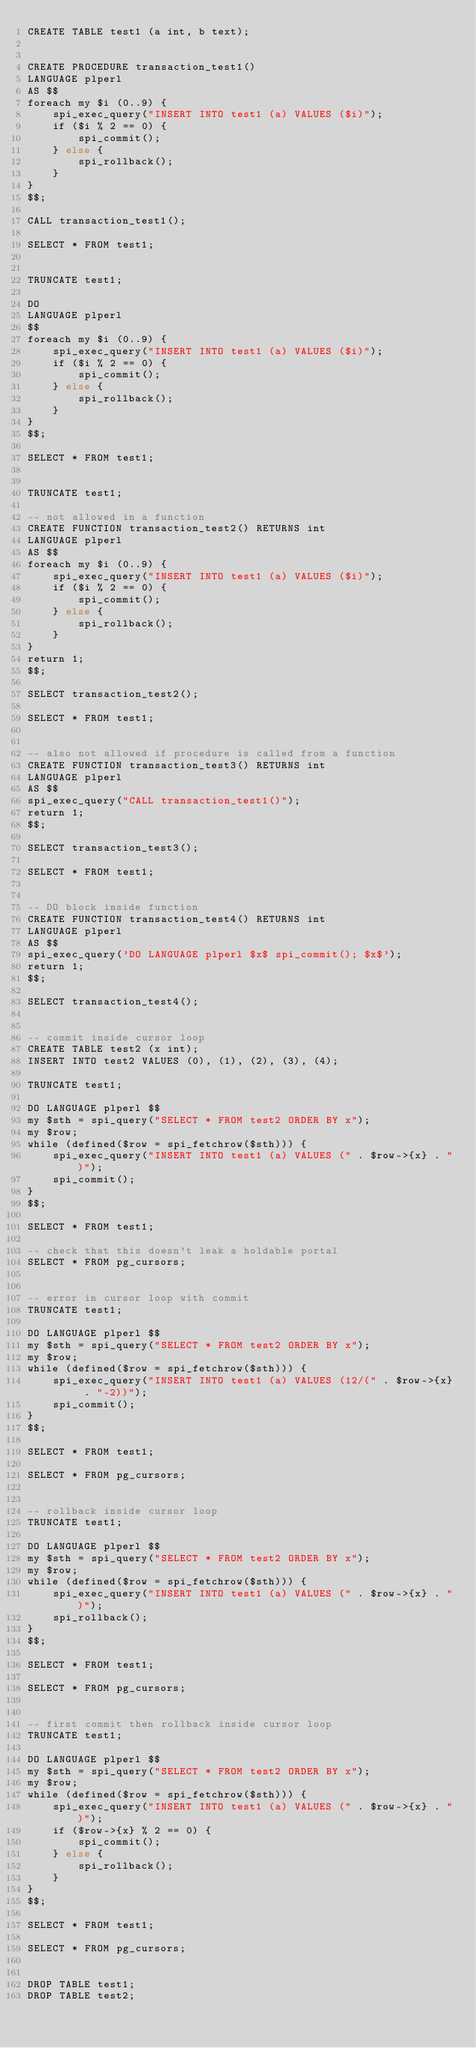Convert code to text. <code><loc_0><loc_0><loc_500><loc_500><_SQL_>CREATE TABLE test1 (a int, b text);


CREATE PROCEDURE transaction_test1()
LANGUAGE plperl
AS $$
foreach my $i (0..9) {
    spi_exec_query("INSERT INTO test1 (a) VALUES ($i)");
    if ($i % 2 == 0) {
        spi_commit();
    } else {
        spi_rollback();
    }
}
$$;

CALL transaction_test1();

SELECT * FROM test1;


TRUNCATE test1;

DO
LANGUAGE plperl
$$
foreach my $i (0..9) {
    spi_exec_query("INSERT INTO test1 (a) VALUES ($i)");
    if ($i % 2 == 0) {
        spi_commit();
    } else {
        spi_rollback();
    }
}
$$;

SELECT * FROM test1;


TRUNCATE test1;

-- not allowed in a function
CREATE FUNCTION transaction_test2() RETURNS int
LANGUAGE plperl
AS $$
foreach my $i (0..9) {
    spi_exec_query("INSERT INTO test1 (a) VALUES ($i)");
    if ($i % 2 == 0) {
        spi_commit();
    } else {
        spi_rollback();
    }
}
return 1;
$$;

SELECT transaction_test2();

SELECT * FROM test1;


-- also not allowed if procedure is called from a function
CREATE FUNCTION transaction_test3() RETURNS int
LANGUAGE plperl
AS $$
spi_exec_query("CALL transaction_test1()");
return 1;
$$;

SELECT transaction_test3();

SELECT * FROM test1;


-- DO block inside function
CREATE FUNCTION transaction_test4() RETURNS int
LANGUAGE plperl
AS $$
spi_exec_query('DO LANGUAGE plperl $x$ spi_commit(); $x$');
return 1;
$$;

SELECT transaction_test4();


-- commit inside cursor loop
CREATE TABLE test2 (x int);
INSERT INTO test2 VALUES (0), (1), (2), (3), (4);

TRUNCATE test1;

DO LANGUAGE plperl $$
my $sth = spi_query("SELECT * FROM test2 ORDER BY x");
my $row;
while (defined($row = spi_fetchrow($sth))) {
    spi_exec_query("INSERT INTO test1 (a) VALUES (" . $row->{x} . ")");
    spi_commit();
}
$$;

SELECT * FROM test1;

-- check that this doesn't leak a holdable portal
SELECT * FROM pg_cursors;


-- error in cursor loop with commit
TRUNCATE test1;

DO LANGUAGE plperl $$
my $sth = spi_query("SELECT * FROM test2 ORDER BY x");
my $row;
while (defined($row = spi_fetchrow($sth))) {
    spi_exec_query("INSERT INTO test1 (a) VALUES (12/(" . $row->{x} . "-2))");
    spi_commit();
}
$$;

SELECT * FROM test1;

SELECT * FROM pg_cursors;


-- rollback inside cursor loop
TRUNCATE test1;

DO LANGUAGE plperl $$
my $sth = spi_query("SELECT * FROM test2 ORDER BY x");
my $row;
while (defined($row = spi_fetchrow($sth))) {
    spi_exec_query("INSERT INTO test1 (a) VALUES (" . $row->{x} . ")");
    spi_rollback();
}
$$;

SELECT * FROM test1;

SELECT * FROM pg_cursors;


-- first commit then rollback inside cursor loop
TRUNCATE test1;

DO LANGUAGE plperl $$
my $sth = spi_query("SELECT * FROM test2 ORDER BY x");
my $row;
while (defined($row = spi_fetchrow($sth))) {
    spi_exec_query("INSERT INTO test1 (a) VALUES (" . $row->{x} . ")");
    if ($row->{x} % 2 == 0) {
        spi_commit();
    } else {
        spi_rollback();
    }
}
$$;

SELECT * FROM test1;

SELECT * FROM pg_cursors;


DROP TABLE test1;
DROP TABLE test2;
</code> 